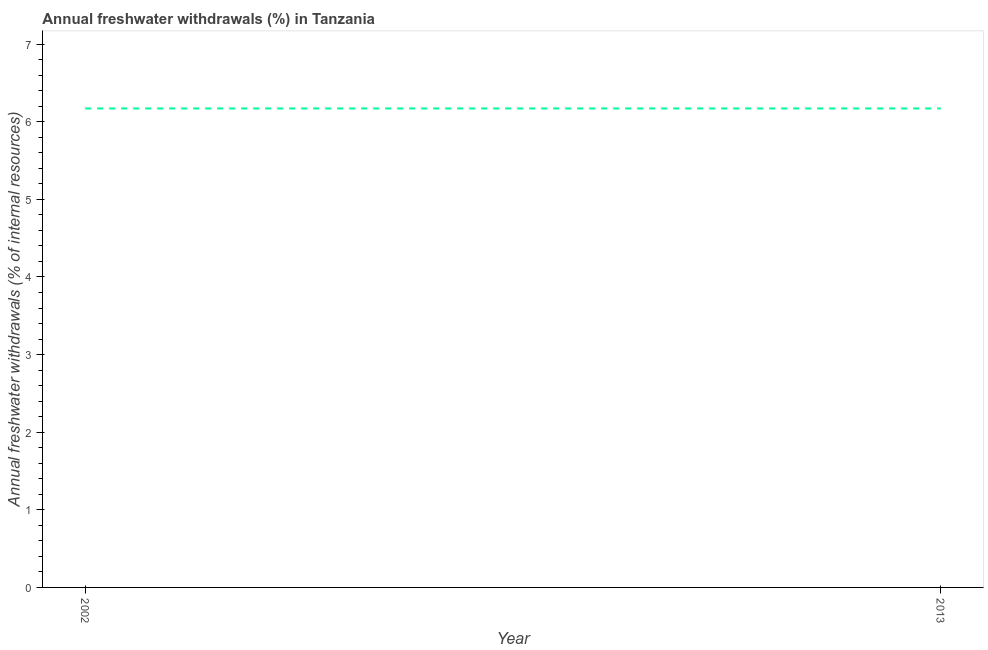What is the annual freshwater withdrawals in 2013?
Offer a terse response. 6.17. Across all years, what is the maximum annual freshwater withdrawals?
Your response must be concise. 6.17. Across all years, what is the minimum annual freshwater withdrawals?
Your answer should be compact. 6.17. In which year was the annual freshwater withdrawals minimum?
Your answer should be compact. 2002. What is the sum of the annual freshwater withdrawals?
Offer a very short reply. 12.34. What is the difference between the annual freshwater withdrawals in 2002 and 2013?
Keep it short and to the point. 0. What is the average annual freshwater withdrawals per year?
Provide a succinct answer. 6.17. What is the median annual freshwater withdrawals?
Provide a succinct answer. 6.17. In how many years, is the annual freshwater withdrawals greater than 5 %?
Make the answer very short. 2. What is the ratio of the annual freshwater withdrawals in 2002 to that in 2013?
Offer a terse response. 1. Is the annual freshwater withdrawals in 2002 less than that in 2013?
Your response must be concise. No. In how many years, is the annual freshwater withdrawals greater than the average annual freshwater withdrawals taken over all years?
Offer a very short reply. 0. Does the annual freshwater withdrawals monotonically increase over the years?
Give a very brief answer. No. How many years are there in the graph?
Offer a very short reply. 2. Does the graph contain any zero values?
Keep it short and to the point. No. What is the title of the graph?
Offer a very short reply. Annual freshwater withdrawals (%) in Tanzania. What is the label or title of the X-axis?
Provide a succinct answer. Year. What is the label or title of the Y-axis?
Offer a terse response. Annual freshwater withdrawals (% of internal resources). What is the Annual freshwater withdrawals (% of internal resources) in 2002?
Offer a very short reply. 6.17. What is the Annual freshwater withdrawals (% of internal resources) of 2013?
Provide a succinct answer. 6.17. 